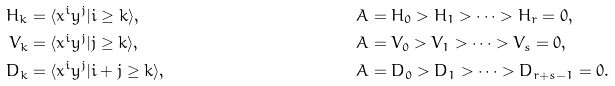<formula> <loc_0><loc_0><loc_500><loc_500>H _ { k } & = \langle x ^ { i } y ^ { j } | i \geq k \rangle , & & A = H _ { 0 } > H _ { 1 } > \cdots > H _ { r } = 0 , \\ V _ { k } & = \langle x ^ { i } y ^ { j } | j \geq k \rangle , & & A = V _ { 0 } > V _ { 1 } > \cdots > V _ { s } = 0 , \\ D _ { k } & = \langle x ^ { i } y ^ { j } | i + j \geq k \rangle , & & A = D _ { 0 } > D _ { 1 } > \cdots > D _ { r + s - 1 } = 0 .</formula> 